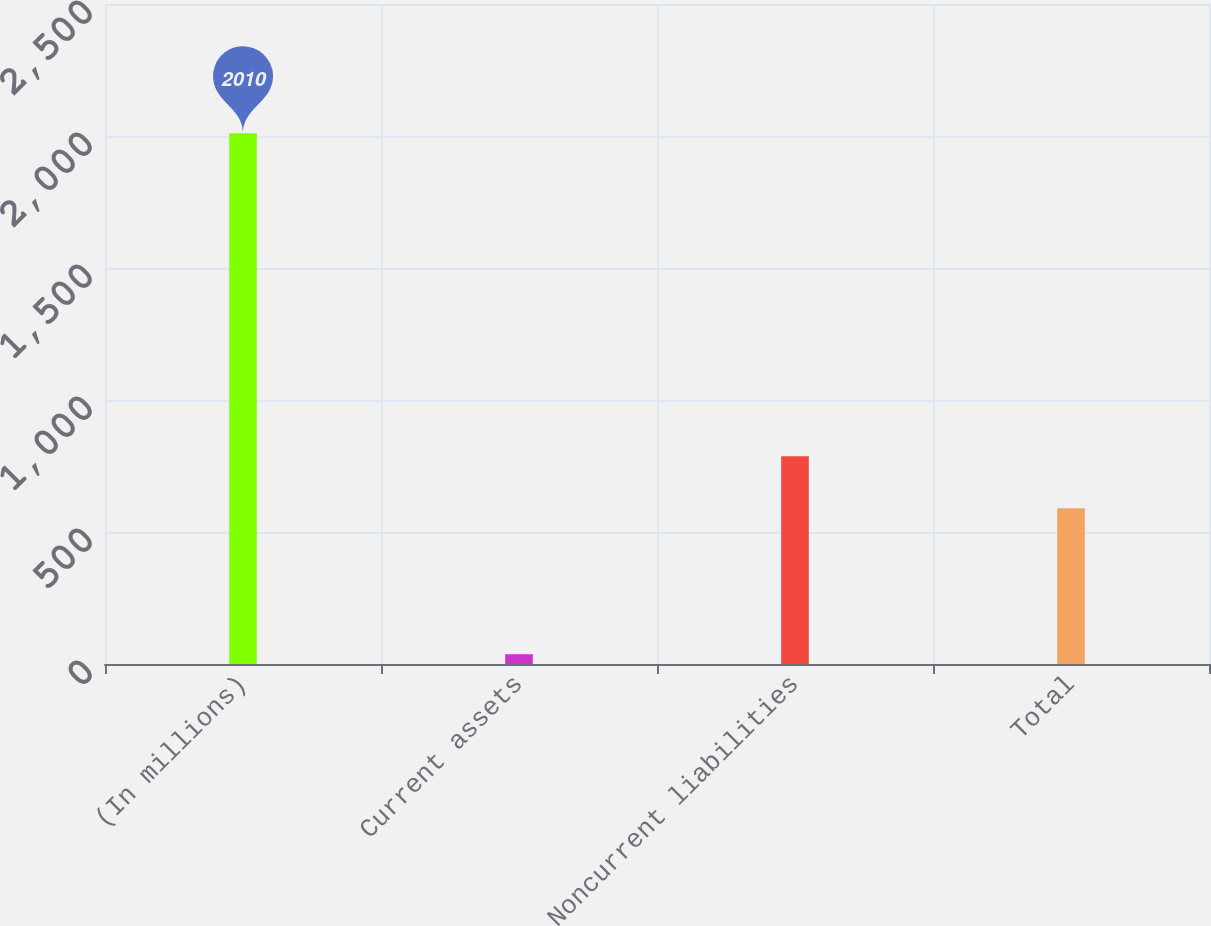Convert chart to OTSL. <chart><loc_0><loc_0><loc_500><loc_500><bar_chart><fcel>(In millions)<fcel>Current assets<fcel>Noncurrent liabilities<fcel>Total<nl><fcel>2010<fcel>37<fcel>787.3<fcel>590<nl></chart> 